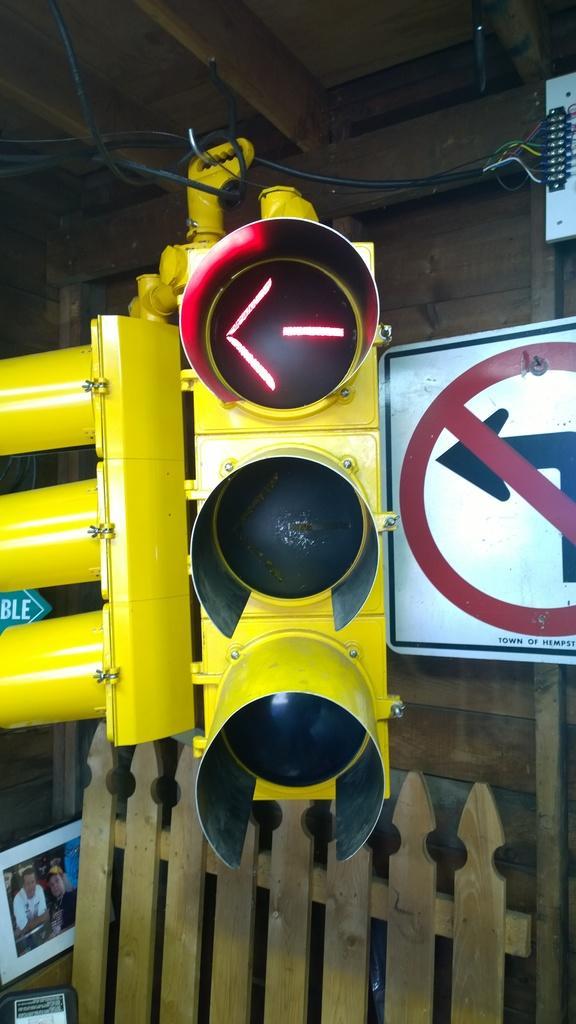Please provide a concise description of this image. In the image there is a traffic light in the middle with a sign board behind it, in the back there is a wooden fence in front of the wall. 